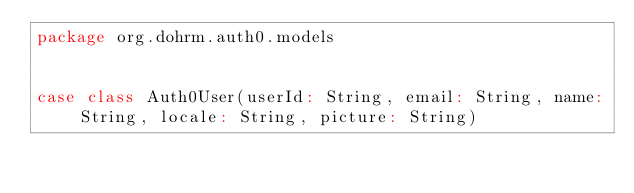<code> <loc_0><loc_0><loc_500><loc_500><_Scala_>package org.dohrm.auth0.models


case class Auth0User(userId: String, email: String, name: String, locale: String, picture: String)
</code> 